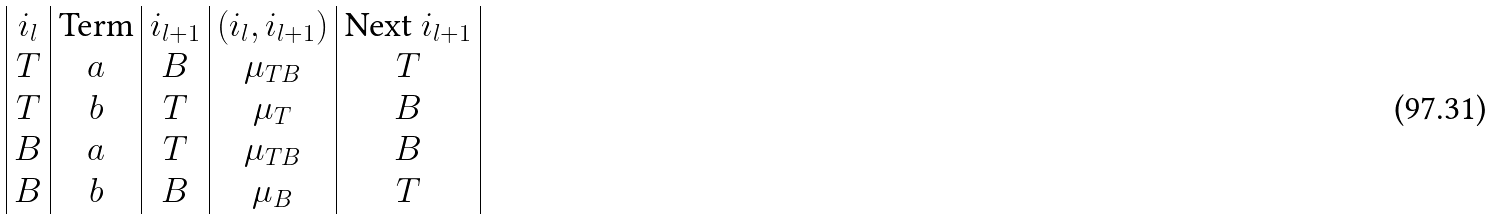Convert formula to latex. <formula><loc_0><loc_0><loc_500><loc_500>\begin{array} { | c | c | c | c | c | } i _ { l } & \text {Term} & i _ { l + 1 } & ( i _ { l } , i _ { l + 1 } ) & \text {Next } i _ { l + 1 } \\ T & a & B & \mu _ { T B } & T \\ T & b & T & \mu _ { T } & B \\ B & a & T & \mu _ { T B } & B \\ B & b & B & \mu _ { B } & T \\ \end{array}</formula> 